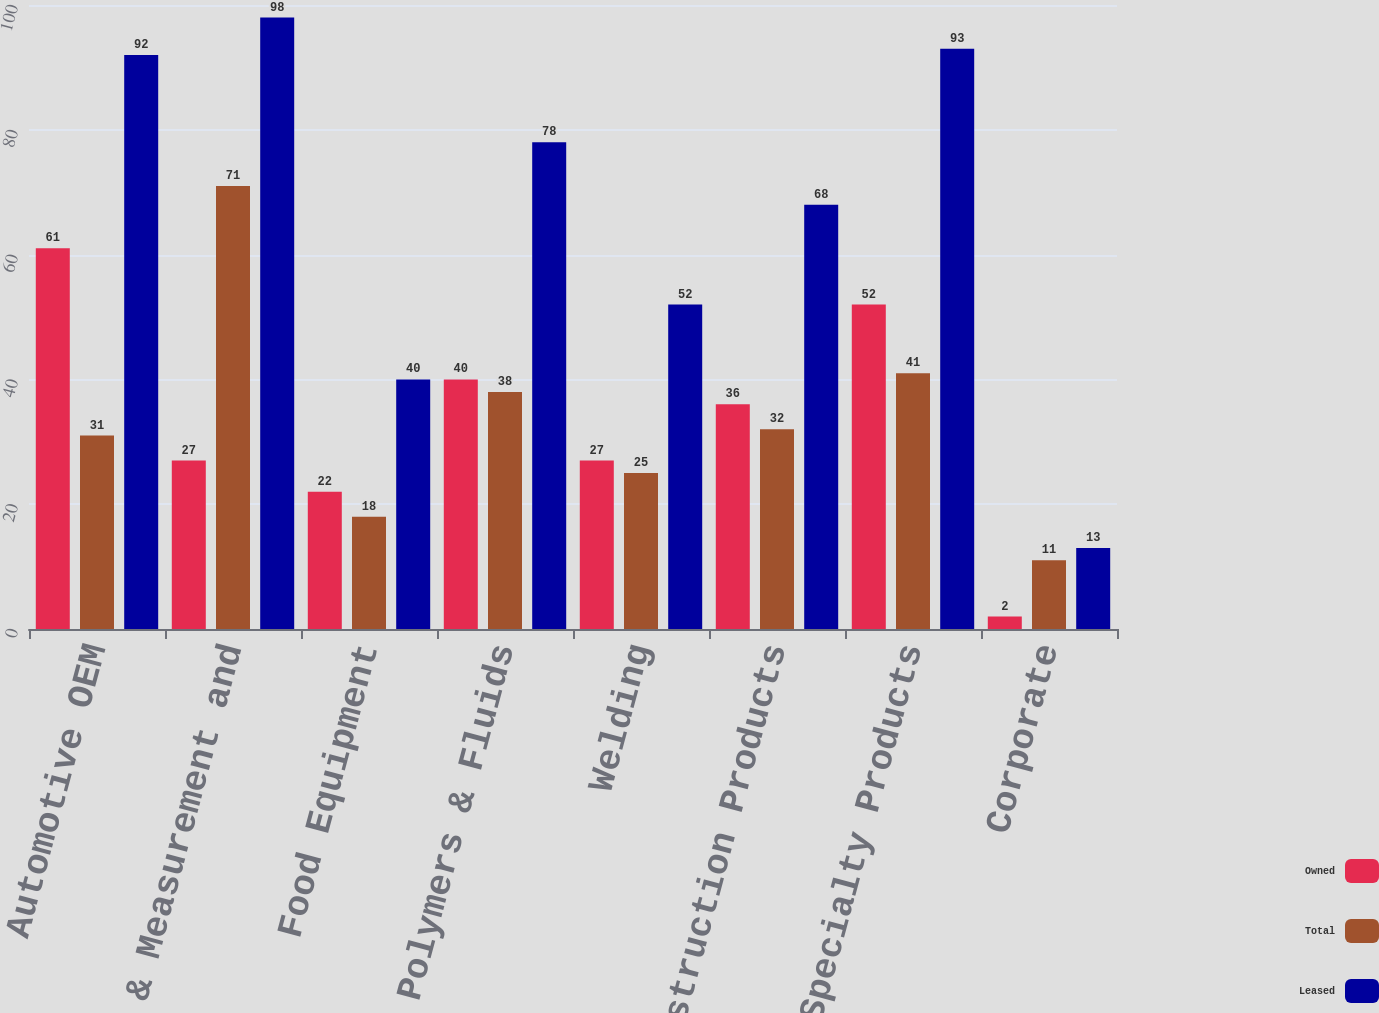Convert chart to OTSL. <chart><loc_0><loc_0><loc_500><loc_500><stacked_bar_chart><ecel><fcel>Automotive OEM<fcel>Test & Measurement and<fcel>Food Equipment<fcel>Polymers & Fluids<fcel>Welding<fcel>Construction Products<fcel>Specialty Products<fcel>Corporate<nl><fcel>Owned<fcel>61<fcel>27<fcel>22<fcel>40<fcel>27<fcel>36<fcel>52<fcel>2<nl><fcel>Total<fcel>31<fcel>71<fcel>18<fcel>38<fcel>25<fcel>32<fcel>41<fcel>11<nl><fcel>Leased<fcel>92<fcel>98<fcel>40<fcel>78<fcel>52<fcel>68<fcel>93<fcel>13<nl></chart> 